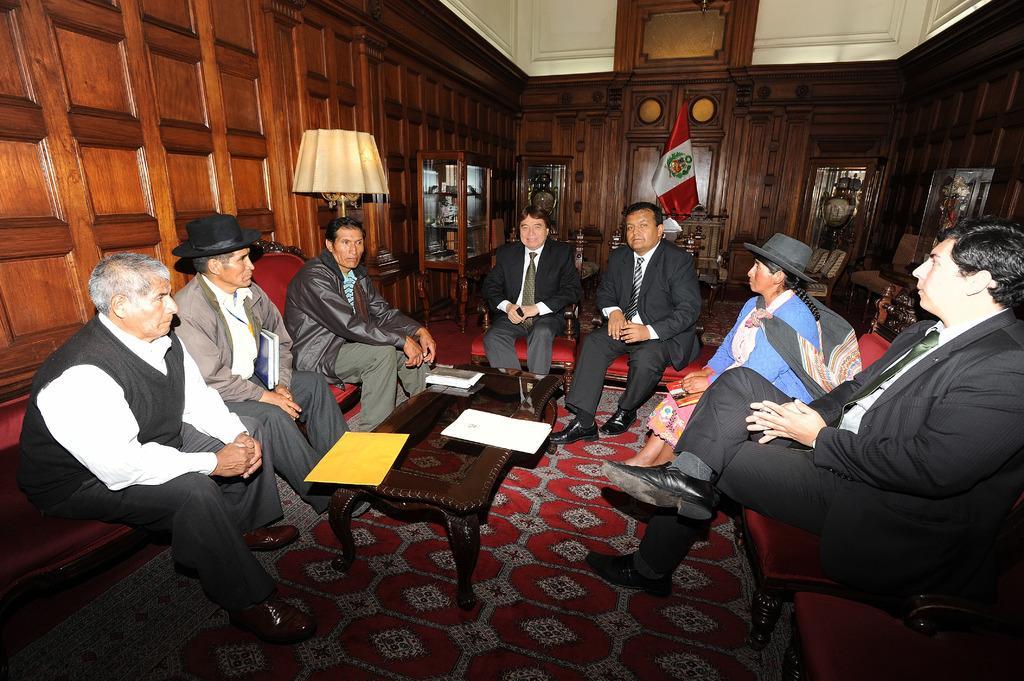Please provide a concise description of this image. In this image we can see a few people sitting on a chair. They wore a suit and they are discussing about something. In the background we can see a flag and a table lamp which is on the left side. 